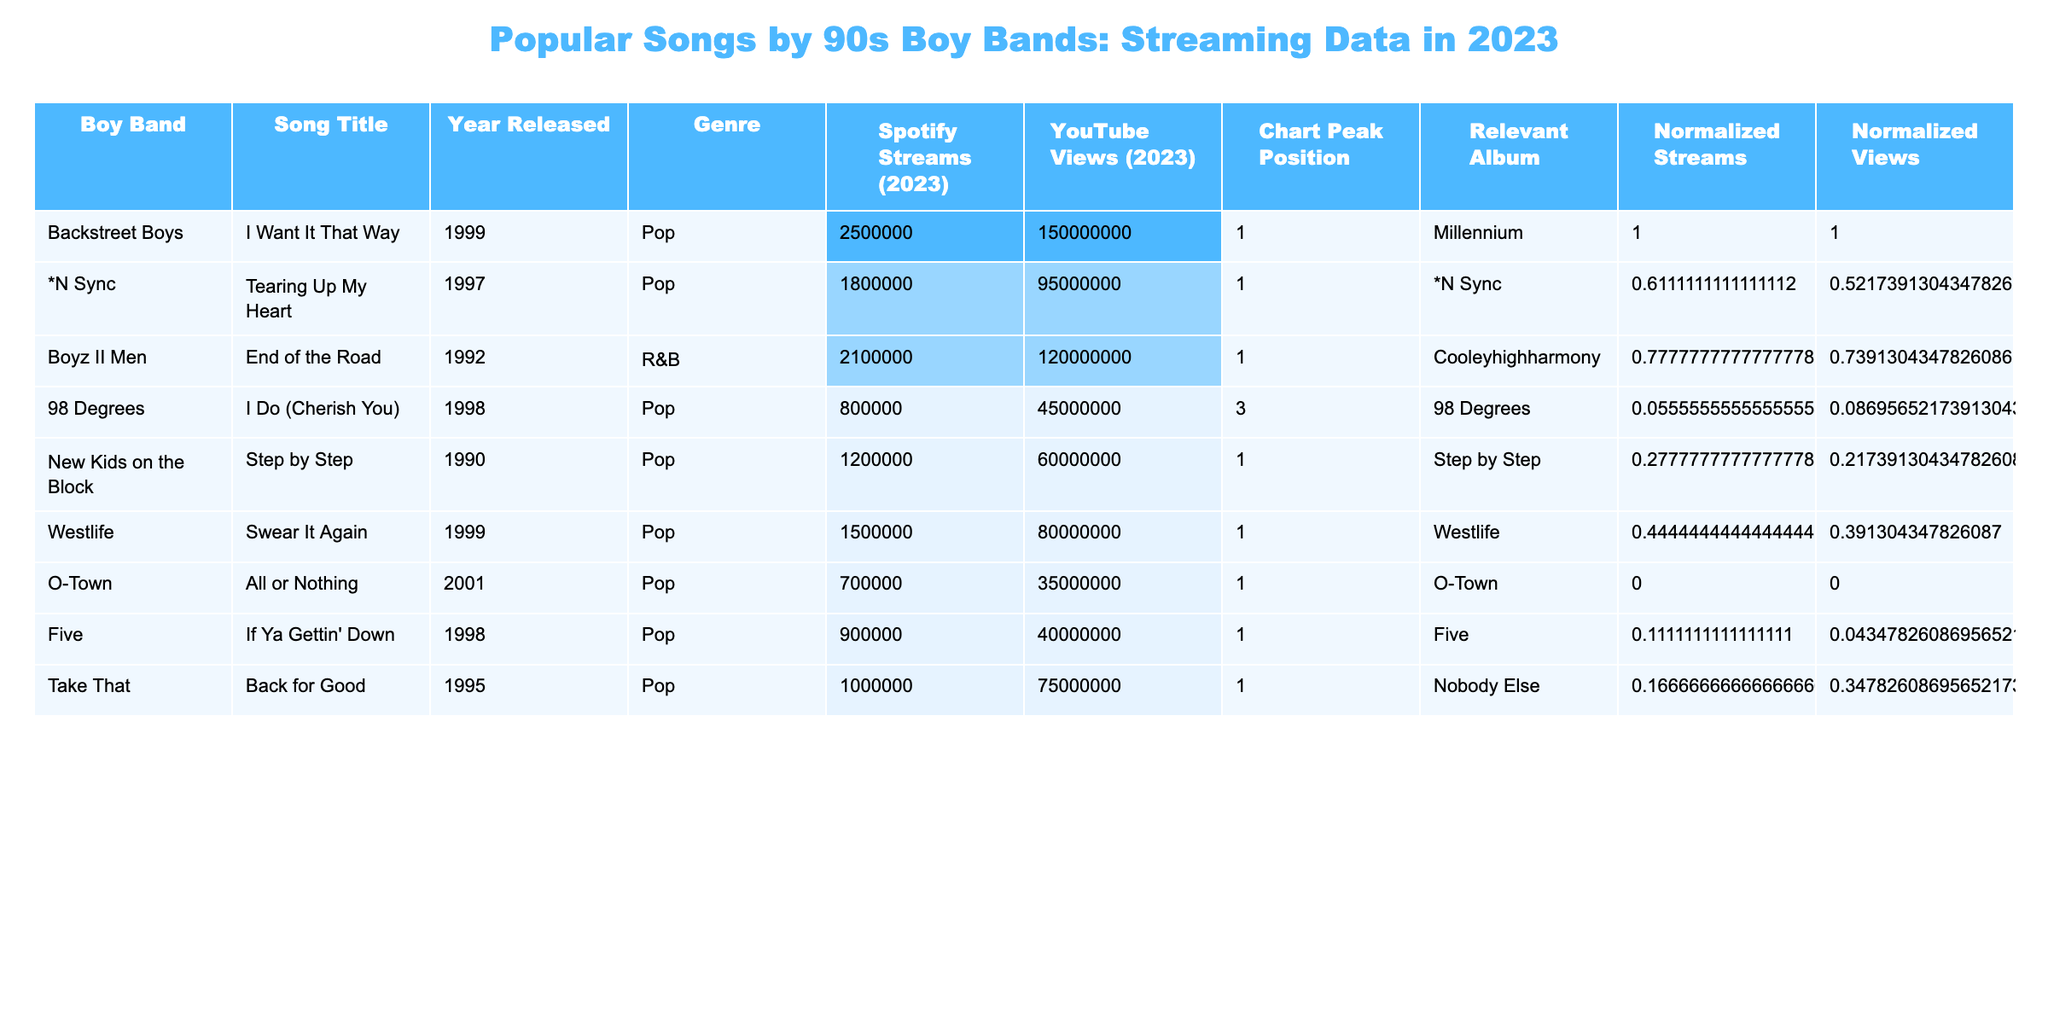What is the most streamed song on Spotify in 2023 from the table? The streaming data shows that "I Want It That Way" by the Backstreet Boys has the highest number of Spotify streams with 2,500,000.
Answer: "I Want It That Way" Which boy band's song ranks number 1 on the chart? According to the table, the songs "I Want It That Way", "Tearing Up My Heart", "End of the Road", "Step by Step", "Swear It Again", and "If Ya Gettin' Down" all reached the number 1 position on the chart.
Answer: Multiple bands What is the total number of YouTube views for the songs listed in the table? To find the total, we sum the YouTube views: 150,000,000 + 95,000,000 + 120,000,000 + 45,000,000 + 60,000,000 + 80,000,000 + 35,000,000 + 40,000,000 = 625,000,000 views.
Answer: 625,000,000 What percentage of Spotify streams do "End of the Road" and "I Do (Cherish You)" represent when combined? First, we calculate the combined streams: 2,100,000 + 800,000 = 2,900,000. Now, we find the percentage of total streams: (2,900,000 / 12,000,000) * 100 = 24.17%.
Answer: 24.17% Is there a song that has the same peak chart position as "I Do (Cherish You)"? The peak position of "I Do (Cherish You)" is 3; reviewing the chart positions shows that no other song listed has a peak of 3.
Answer: No Which genre dominates the songs listed in the table? By analyzing the genre column, we see that all songs are either Pop or R&B. The majority are listed as Pop.
Answer: Pop Do any of the songs have higher YouTube views than their Spotify streams? Comparing the YouTube views to Spotify streams: "I Want It That Way" (150M views > 2.5M streams), "End of the Road" (120M views > 2.1M streams), and others have more views than streams.
Answer: Yes What is the average number of Spotify streams for the songs listed? The average is calculated by summing all Spotify streams (2,500,000 + 1,800,000 + 2,100,000 + 800,000 + 1,200,000 + 1,500,000 + 700,000 + 900,000 = 12,600,000) and dividing by the number of songs (8), giving an average of 1,575,000.
Answer: 1,575,000 Which song from the table has the lowest YouTube views? By examining the YouTube views, "All or Nothing" has the lowest at 35,000,000.
Answer: "All or Nothing" How many songs were released in the 1990s? Counting the release years, we see the songs "I Want It That Way", "Tearing Up My Heart", "End of the Road", "I Do (Cherish You)", "Step by Step", "Swear It Again", "Back for Good", which means a total of 6 songs were released in the 1990s.
Answer: 6 